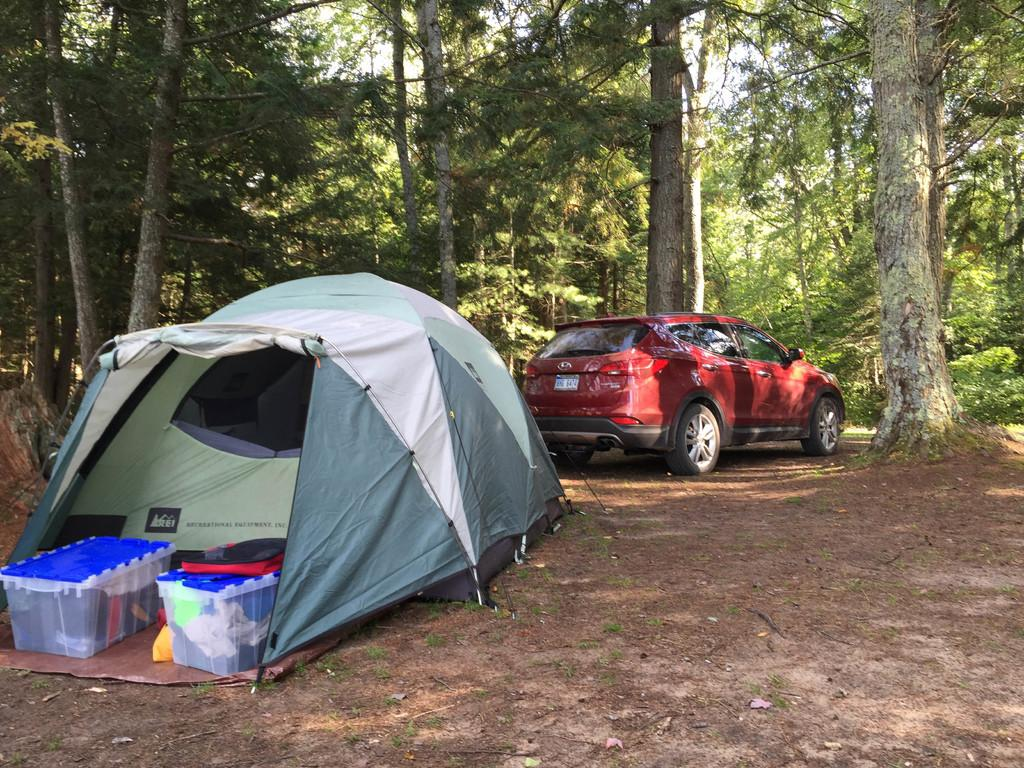What is the main subject of the image? There is a car in the image. What else can be seen on the left side of the image? There is a tent on the left side of the image. What is inside the box in the image? There are objects in a box in the image. What can be seen in the background of the image? There are trees visible in the background of the image. How many seeds are scattered on the ground in the image? There are no seeds visible in the image. 